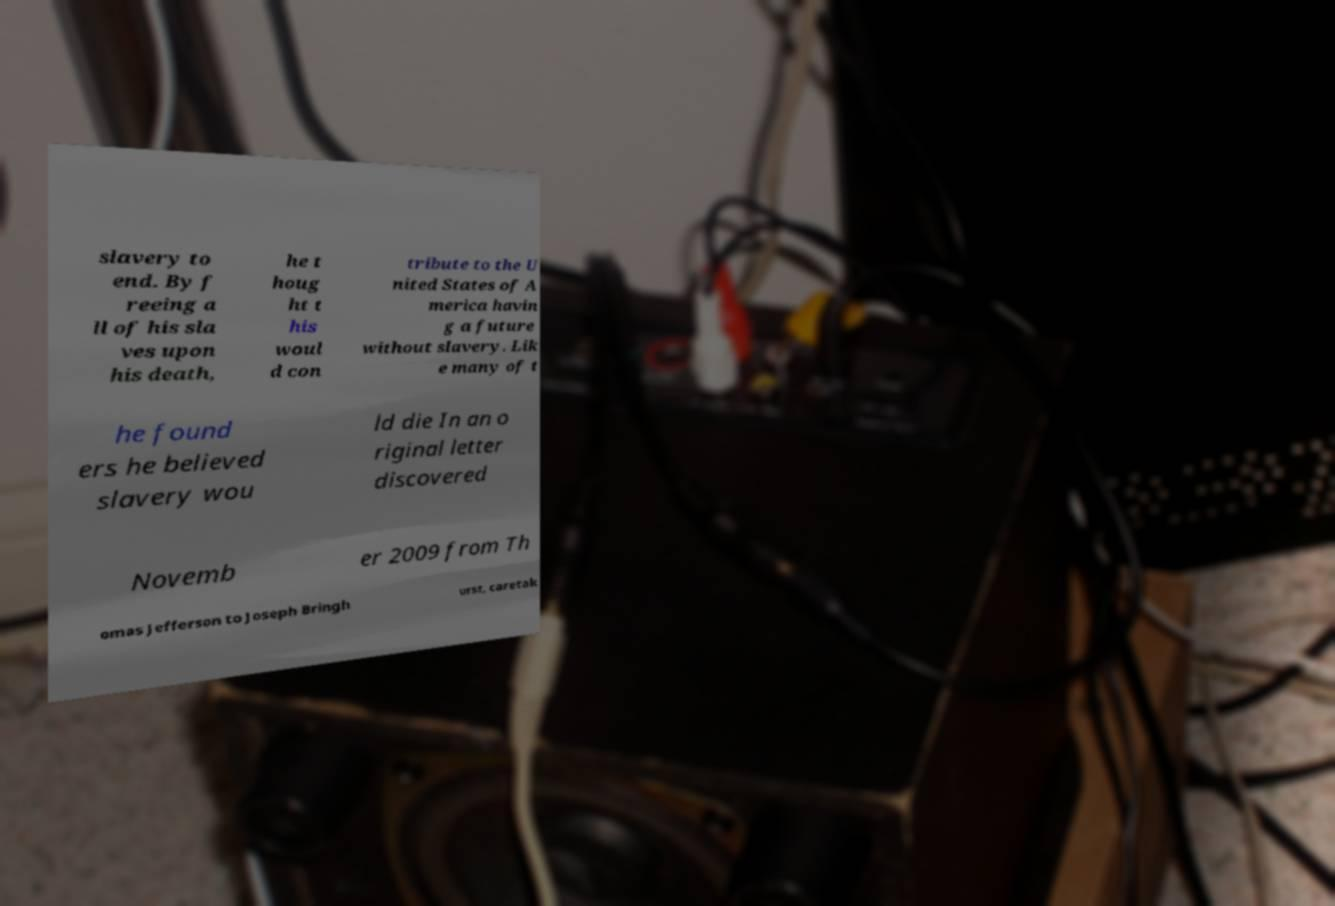What messages or text are displayed in this image? I need them in a readable, typed format. slavery to end. By f reeing a ll of his sla ves upon his death, he t houg ht t his woul d con tribute to the U nited States of A merica havin g a future without slavery. Lik e many of t he found ers he believed slavery wou ld die In an o riginal letter discovered Novemb er 2009 from Th omas Jefferson to Joseph Bringh urst, caretak 